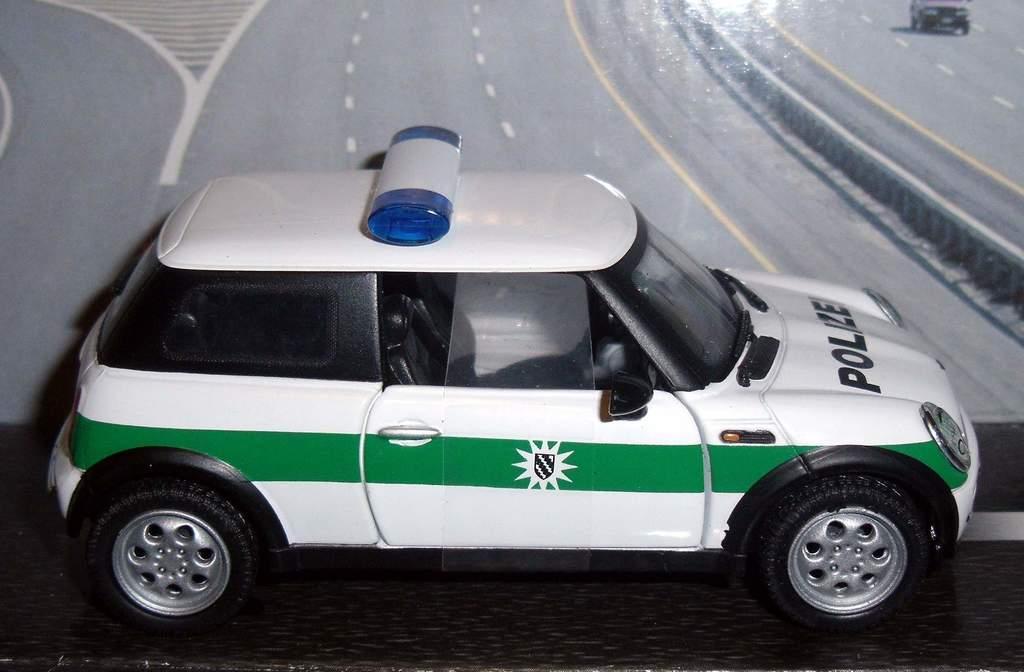How would you summarize this image in a sentence or two? This image consists of a car. There is police written on it. It is in white and green color. 